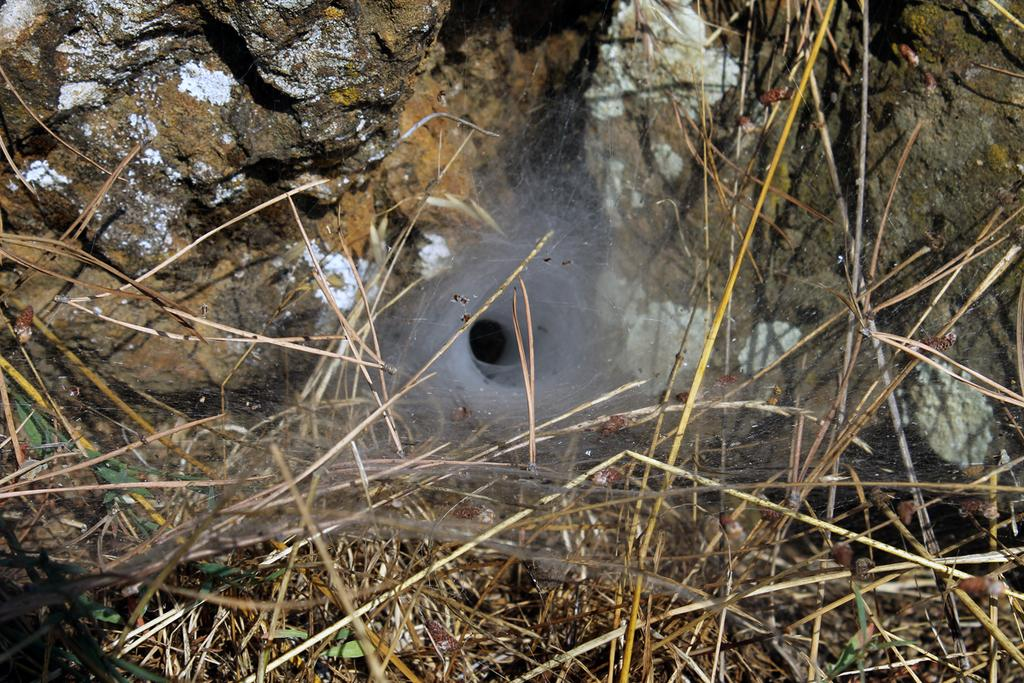What type of vegetation is present in the image? There is grass in the image. Can you describe any other elements in the background of the image? There is a rock visible in the background of the image. What type of cheese is being used to make a joke in the image? There is no cheese or joke present in the image; it only features grass and a rock in the background. 